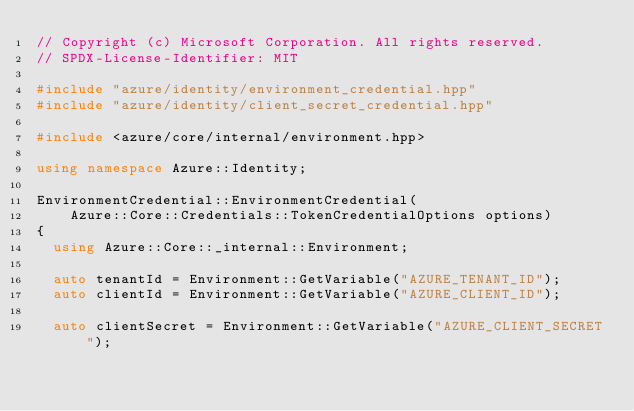Convert code to text. <code><loc_0><loc_0><loc_500><loc_500><_C++_>// Copyright (c) Microsoft Corporation. All rights reserved.
// SPDX-License-Identifier: MIT

#include "azure/identity/environment_credential.hpp"
#include "azure/identity/client_secret_credential.hpp"

#include <azure/core/internal/environment.hpp>

using namespace Azure::Identity;

EnvironmentCredential::EnvironmentCredential(
    Azure::Core::Credentials::TokenCredentialOptions options)
{
  using Azure::Core::_internal::Environment;

  auto tenantId = Environment::GetVariable("AZURE_TENANT_ID");
  auto clientId = Environment::GetVariable("AZURE_CLIENT_ID");

  auto clientSecret = Environment::GetVariable("AZURE_CLIENT_SECRET");</code> 